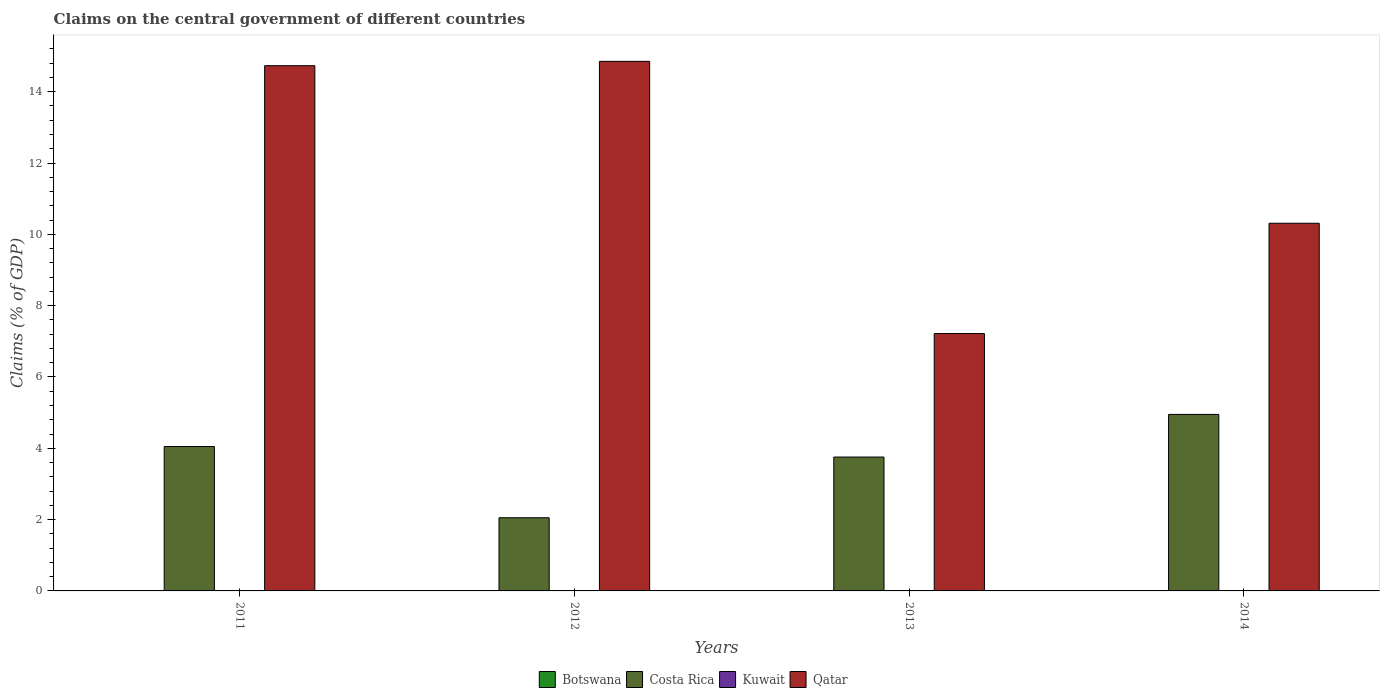How many bars are there on the 1st tick from the left?
Your answer should be very brief. 2. What is the label of the 2nd group of bars from the left?
Provide a succinct answer. 2012. Across all years, what is the maximum percentage of GDP claimed on the central government in Costa Rica?
Your response must be concise. 4.95. Across all years, what is the minimum percentage of GDP claimed on the central government in Kuwait?
Your response must be concise. 0. In which year was the percentage of GDP claimed on the central government in Qatar maximum?
Keep it short and to the point. 2012. What is the total percentage of GDP claimed on the central government in Costa Rica in the graph?
Your answer should be very brief. 14.81. What is the difference between the percentage of GDP claimed on the central government in Qatar in 2011 and that in 2013?
Your answer should be very brief. 7.51. What is the average percentage of GDP claimed on the central government in Costa Rica per year?
Your response must be concise. 3.7. What is the ratio of the percentage of GDP claimed on the central government in Qatar in 2011 to that in 2012?
Your answer should be compact. 0.99. Is the percentage of GDP claimed on the central government in Costa Rica in 2011 less than that in 2014?
Offer a terse response. Yes. What is the difference between the highest and the second highest percentage of GDP claimed on the central government in Qatar?
Offer a very short reply. 0.12. What is the difference between the highest and the lowest percentage of GDP claimed on the central government in Qatar?
Give a very brief answer. 7.63. Is the sum of the percentage of GDP claimed on the central government in Qatar in 2011 and 2012 greater than the maximum percentage of GDP claimed on the central government in Kuwait across all years?
Your answer should be compact. Yes. How many years are there in the graph?
Your answer should be compact. 4. What is the difference between two consecutive major ticks on the Y-axis?
Give a very brief answer. 2. Are the values on the major ticks of Y-axis written in scientific E-notation?
Your answer should be compact. No. Does the graph contain grids?
Provide a succinct answer. No. Where does the legend appear in the graph?
Your answer should be very brief. Bottom center. How many legend labels are there?
Give a very brief answer. 4. What is the title of the graph?
Provide a short and direct response. Claims on the central government of different countries. What is the label or title of the Y-axis?
Ensure brevity in your answer.  Claims (% of GDP). What is the Claims (% of GDP) in Costa Rica in 2011?
Your answer should be compact. 4.05. What is the Claims (% of GDP) in Kuwait in 2011?
Provide a short and direct response. 0. What is the Claims (% of GDP) in Qatar in 2011?
Your answer should be compact. 14.73. What is the Claims (% of GDP) of Costa Rica in 2012?
Offer a very short reply. 2.05. What is the Claims (% of GDP) in Qatar in 2012?
Provide a short and direct response. 14.85. What is the Claims (% of GDP) in Costa Rica in 2013?
Your answer should be very brief. 3.75. What is the Claims (% of GDP) of Kuwait in 2013?
Offer a very short reply. 0. What is the Claims (% of GDP) in Qatar in 2013?
Offer a terse response. 7.22. What is the Claims (% of GDP) of Costa Rica in 2014?
Provide a succinct answer. 4.95. What is the Claims (% of GDP) in Qatar in 2014?
Your response must be concise. 10.31. Across all years, what is the maximum Claims (% of GDP) of Costa Rica?
Provide a short and direct response. 4.95. Across all years, what is the maximum Claims (% of GDP) in Qatar?
Your answer should be very brief. 14.85. Across all years, what is the minimum Claims (% of GDP) of Costa Rica?
Provide a succinct answer. 2.05. Across all years, what is the minimum Claims (% of GDP) in Qatar?
Ensure brevity in your answer.  7.22. What is the total Claims (% of GDP) of Botswana in the graph?
Provide a short and direct response. 0. What is the total Claims (% of GDP) of Costa Rica in the graph?
Give a very brief answer. 14.81. What is the total Claims (% of GDP) of Kuwait in the graph?
Your answer should be compact. 0. What is the total Claims (% of GDP) in Qatar in the graph?
Offer a terse response. 47.11. What is the difference between the Claims (% of GDP) of Costa Rica in 2011 and that in 2012?
Provide a short and direct response. 2. What is the difference between the Claims (% of GDP) in Qatar in 2011 and that in 2012?
Your answer should be compact. -0.12. What is the difference between the Claims (% of GDP) of Costa Rica in 2011 and that in 2013?
Provide a short and direct response. 0.3. What is the difference between the Claims (% of GDP) of Qatar in 2011 and that in 2013?
Provide a short and direct response. 7.51. What is the difference between the Claims (% of GDP) in Costa Rica in 2011 and that in 2014?
Keep it short and to the point. -0.9. What is the difference between the Claims (% of GDP) in Qatar in 2011 and that in 2014?
Offer a very short reply. 4.42. What is the difference between the Claims (% of GDP) of Costa Rica in 2012 and that in 2013?
Provide a short and direct response. -1.7. What is the difference between the Claims (% of GDP) in Qatar in 2012 and that in 2013?
Keep it short and to the point. 7.63. What is the difference between the Claims (% of GDP) of Costa Rica in 2012 and that in 2014?
Your response must be concise. -2.9. What is the difference between the Claims (% of GDP) in Qatar in 2012 and that in 2014?
Offer a terse response. 4.54. What is the difference between the Claims (% of GDP) of Costa Rica in 2013 and that in 2014?
Provide a short and direct response. -1.2. What is the difference between the Claims (% of GDP) in Qatar in 2013 and that in 2014?
Your response must be concise. -3.09. What is the difference between the Claims (% of GDP) in Costa Rica in 2011 and the Claims (% of GDP) in Qatar in 2012?
Ensure brevity in your answer.  -10.8. What is the difference between the Claims (% of GDP) of Costa Rica in 2011 and the Claims (% of GDP) of Qatar in 2013?
Your response must be concise. -3.17. What is the difference between the Claims (% of GDP) in Costa Rica in 2011 and the Claims (% of GDP) in Qatar in 2014?
Your answer should be very brief. -6.26. What is the difference between the Claims (% of GDP) of Costa Rica in 2012 and the Claims (% of GDP) of Qatar in 2013?
Make the answer very short. -5.17. What is the difference between the Claims (% of GDP) of Costa Rica in 2012 and the Claims (% of GDP) of Qatar in 2014?
Provide a succinct answer. -8.26. What is the difference between the Claims (% of GDP) in Costa Rica in 2013 and the Claims (% of GDP) in Qatar in 2014?
Your response must be concise. -6.56. What is the average Claims (% of GDP) of Botswana per year?
Keep it short and to the point. 0. What is the average Claims (% of GDP) in Costa Rica per year?
Offer a terse response. 3.7. What is the average Claims (% of GDP) in Qatar per year?
Provide a succinct answer. 11.78. In the year 2011, what is the difference between the Claims (% of GDP) of Costa Rica and Claims (% of GDP) of Qatar?
Make the answer very short. -10.68. In the year 2012, what is the difference between the Claims (% of GDP) of Costa Rica and Claims (% of GDP) of Qatar?
Give a very brief answer. -12.8. In the year 2013, what is the difference between the Claims (% of GDP) of Costa Rica and Claims (% of GDP) of Qatar?
Provide a short and direct response. -3.46. In the year 2014, what is the difference between the Claims (% of GDP) of Costa Rica and Claims (% of GDP) of Qatar?
Keep it short and to the point. -5.36. What is the ratio of the Claims (% of GDP) of Costa Rica in 2011 to that in 2012?
Offer a terse response. 1.97. What is the ratio of the Claims (% of GDP) of Qatar in 2011 to that in 2012?
Offer a very short reply. 0.99. What is the ratio of the Claims (% of GDP) in Costa Rica in 2011 to that in 2013?
Give a very brief answer. 1.08. What is the ratio of the Claims (% of GDP) in Qatar in 2011 to that in 2013?
Your answer should be compact. 2.04. What is the ratio of the Claims (% of GDP) of Costa Rica in 2011 to that in 2014?
Make the answer very short. 0.82. What is the ratio of the Claims (% of GDP) of Qatar in 2011 to that in 2014?
Offer a terse response. 1.43. What is the ratio of the Claims (% of GDP) in Costa Rica in 2012 to that in 2013?
Keep it short and to the point. 0.55. What is the ratio of the Claims (% of GDP) in Qatar in 2012 to that in 2013?
Keep it short and to the point. 2.06. What is the ratio of the Claims (% of GDP) in Costa Rica in 2012 to that in 2014?
Provide a short and direct response. 0.41. What is the ratio of the Claims (% of GDP) of Qatar in 2012 to that in 2014?
Ensure brevity in your answer.  1.44. What is the ratio of the Claims (% of GDP) of Costa Rica in 2013 to that in 2014?
Provide a short and direct response. 0.76. What is the ratio of the Claims (% of GDP) in Qatar in 2013 to that in 2014?
Provide a short and direct response. 0.7. What is the difference between the highest and the second highest Claims (% of GDP) in Costa Rica?
Your answer should be very brief. 0.9. What is the difference between the highest and the second highest Claims (% of GDP) of Qatar?
Ensure brevity in your answer.  0.12. What is the difference between the highest and the lowest Claims (% of GDP) in Costa Rica?
Your answer should be very brief. 2.9. What is the difference between the highest and the lowest Claims (% of GDP) in Qatar?
Make the answer very short. 7.63. 